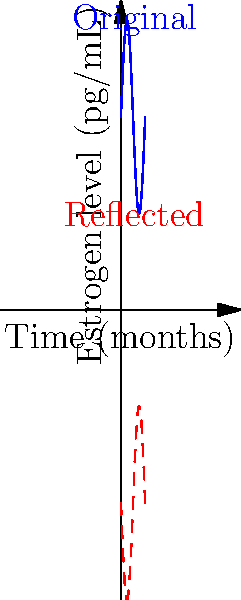The blue curve in the graph represents a patient's estrogen levels over time during menopause transition. If this curve is reflected across the x-axis, which mathematical transformation would correctly describe the resulting red dashed curve? To solve this problem, let's follow these steps:

1) The original function (blue curve) can be represented as $f(x) = 50 + 25\sin(x)$, where $x$ is time and $f(x)$ is the estrogen level.

2) Reflection across the x-axis is a transformation that changes the sign of the y-coordinate while keeping the x-coordinate the same.

3) Mathematically, this transformation can be expressed as:
   $$(x, y) \rightarrow (x, -y)$$

4) Applying this to our function, we get:
   $f(x) = 50 + 25\sin(x)$ becomes $-f(x) = -(50 + 25\sin(x))$

5) Simplifying:
   $-f(x) = -50 - 25\sin(x)$

6) To make this function symmetric to the original about the x-axis, we need to add 100 (twice the y-intercept of the original function):
   $100 - f(x) = 100 - (50 + 25\sin(x)) = 50 - 25\sin(x)$

Therefore, the transformation that describes the red dashed curve is $y = 50 - 25\sin(x)$ or more generally, $y = 100 - f(x)$.
Answer: $y = 100 - f(x)$ 